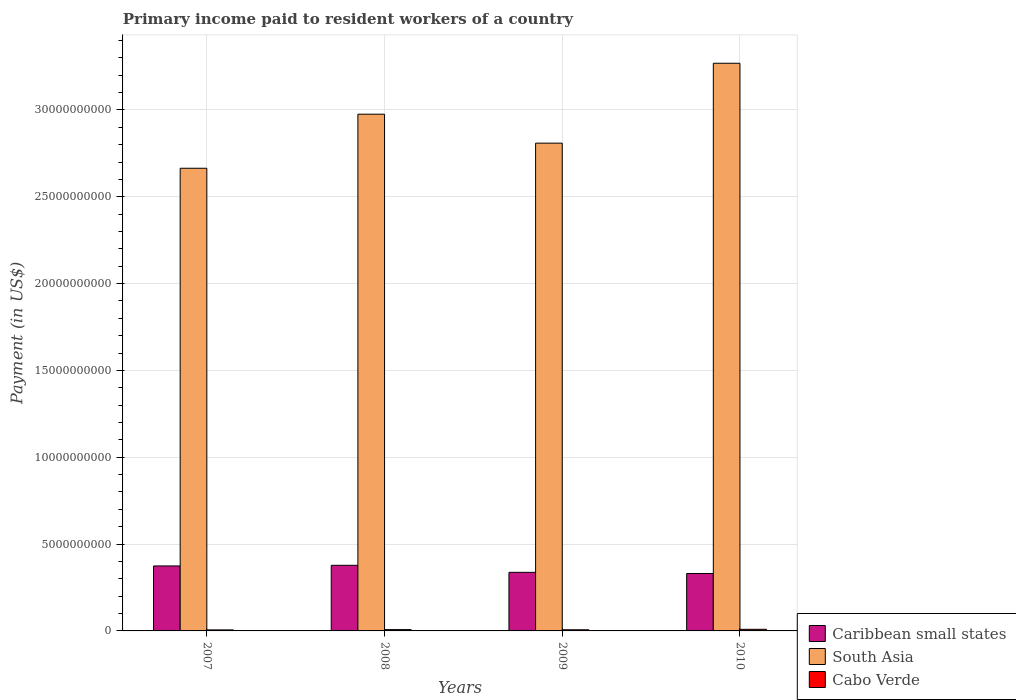How many different coloured bars are there?
Your answer should be compact. 3. How many groups of bars are there?
Keep it short and to the point. 4. Are the number of bars on each tick of the X-axis equal?
Keep it short and to the point. Yes. How many bars are there on the 3rd tick from the right?
Offer a terse response. 3. What is the label of the 1st group of bars from the left?
Your response must be concise. 2007. What is the amount paid to workers in Caribbean small states in 2010?
Your answer should be compact. 3.31e+09. Across all years, what is the maximum amount paid to workers in Cabo Verde?
Offer a very short reply. 9.31e+07. Across all years, what is the minimum amount paid to workers in Caribbean small states?
Provide a succinct answer. 3.31e+09. In which year was the amount paid to workers in South Asia maximum?
Offer a terse response. 2010. In which year was the amount paid to workers in Caribbean small states minimum?
Your response must be concise. 2010. What is the total amount paid to workers in South Asia in the graph?
Offer a very short reply. 1.17e+11. What is the difference between the amount paid to workers in Caribbean small states in 2007 and that in 2010?
Ensure brevity in your answer.  4.35e+08. What is the difference between the amount paid to workers in Cabo Verde in 2007 and the amount paid to workers in South Asia in 2010?
Provide a short and direct response. -3.26e+1. What is the average amount paid to workers in Caribbean small states per year?
Ensure brevity in your answer.  3.55e+09. In the year 2008, what is the difference between the amount paid to workers in Cabo Verde and amount paid to workers in South Asia?
Your answer should be very brief. -2.97e+1. In how many years, is the amount paid to workers in Caribbean small states greater than 26000000000 US$?
Make the answer very short. 0. What is the ratio of the amount paid to workers in Cabo Verde in 2008 to that in 2009?
Provide a succinct answer. 1.14. What is the difference between the highest and the second highest amount paid to workers in South Asia?
Offer a very short reply. 2.93e+09. What is the difference between the highest and the lowest amount paid to workers in Cabo Verde?
Keep it short and to the point. 3.42e+07. Is the sum of the amount paid to workers in Caribbean small states in 2008 and 2009 greater than the maximum amount paid to workers in Cabo Verde across all years?
Offer a terse response. Yes. What does the 3rd bar from the left in 2007 represents?
Keep it short and to the point. Cabo Verde. What does the 2nd bar from the right in 2008 represents?
Offer a terse response. South Asia. Is it the case that in every year, the sum of the amount paid to workers in South Asia and amount paid to workers in Cabo Verde is greater than the amount paid to workers in Caribbean small states?
Provide a short and direct response. Yes. Are all the bars in the graph horizontal?
Provide a short and direct response. No. What is the difference between two consecutive major ticks on the Y-axis?
Your answer should be compact. 5.00e+09. Are the values on the major ticks of Y-axis written in scientific E-notation?
Offer a terse response. No. Does the graph contain any zero values?
Keep it short and to the point. No. Does the graph contain grids?
Make the answer very short. Yes. Where does the legend appear in the graph?
Provide a succinct answer. Bottom right. How many legend labels are there?
Offer a terse response. 3. How are the legend labels stacked?
Your answer should be very brief. Vertical. What is the title of the graph?
Your answer should be very brief. Primary income paid to resident workers of a country. Does "Tuvalu" appear as one of the legend labels in the graph?
Provide a succinct answer. No. What is the label or title of the Y-axis?
Keep it short and to the point. Payment (in US$). What is the Payment (in US$) of Caribbean small states in 2007?
Offer a very short reply. 3.74e+09. What is the Payment (in US$) of South Asia in 2007?
Provide a short and direct response. 2.66e+1. What is the Payment (in US$) in Cabo Verde in 2007?
Ensure brevity in your answer.  5.89e+07. What is the Payment (in US$) in Caribbean small states in 2008?
Your response must be concise. 3.78e+09. What is the Payment (in US$) of South Asia in 2008?
Your response must be concise. 2.98e+1. What is the Payment (in US$) of Cabo Verde in 2008?
Offer a very short reply. 7.57e+07. What is the Payment (in US$) of Caribbean small states in 2009?
Your response must be concise. 3.37e+09. What is the Payment (in US$) of South Asia in 2009?
Offer a very short reply. 2.81e+1. What is the Payment (in US$) in Cabo Verde in 2009?
Provide a succinct answer. 6.63e+07. What is the Payment (in US$) in Caribbean small states in 2010?
Your answer should be compact. 3.31e+09. What is the Payment (in US$) of South Asia in 2010?
Make the answer very short. 3.27e+1. What is the Payment (in US$) in Cabo Verde in 2010?
Your response must be concise. 9.31e+07. Across all years, what is the maximum Payment (in US$) in Caribbean small states?
Offer a very short reply. 3.78e+09. Across all years, what is the maximum Payment (in US$) of South Asia?
Your answer should be compact. 3.27e+1. Across all years, what is the maximum Payment (in US$) in Cabo Verde?
Provide a short and direct response. 9.31e+07. Across all years, what is the minimum Payment (in US$) in Caribbean small states?
Make the answer very short. 3.31e+09. Across all years, what is the minimum Payment (in US$) in South Asia?
Keep it short and to the point. 2.66e+1. Across all years, what is the minimum Payment (in US$) in Cabo Verde?
Make the answer very short. 5.89e+07. What is the total Payment (in US$) in Caribbean small states in the graph?
Your answer should be compact. 1.42e+1. What is the total Payment (in US$) of South Asia in the graph?
Ensure brevity in your answer.  1.17e+11. What is the total Payment (in US$) in Cabo Verde in the graph?
Keep it short and to the point. 2.94e+08. What is the difference between the Payment (in US$) in Caribbean small states in 2007 and that in 2008?
Provide a short and direct response. -3.64e+07. What is the difference between the Payment (in US$) of South Asia in 2007 and that in 2008?
Ensure brevity in your answer.  -3.11e+09. What is the difference between the Payment (in US$) in Cabo Verde in 2007 and that in 2008?
Make the answer very short. -1.68e+07. What is the difference between the Payment (in US$) in Caribbean small states in 2007 and that in 2009?
Your answer should be compact. 3.68e+08. What is the difference between the Payment (in US$) in South Asia in 2007 and that in 2009?
Your answer should be very brief. -1.45e+09. What is the difference between the Payment (in US$) in Cabo Verde in 2007 and that in 2009?
Your answer should be very brief. -7.39e+06. What is the difference between the Payment (in US$) of Caribbean small states in 2007 and that in 2010?
Offer a very short reply. 4.35e+08. What is the difference between the Payment (in US$) of South Asia in 2007 and that in 2010?
Your answer should be very brief. -6.05e+09. What is the difference between the Payment (in US$) in Cabo Verde in 2007 and that in 2010?
Give a very brief answer. -3.42e+07. What is the difference between the Payment (in US$) of Caribbean small states in 2008 and that in 2009?
Make the answer very short. 4.05e+08. What is the difference between the Payment (in US$) in South Asia in 2008 and that in 2009?
Provide a short and direct response. 1.67e+09. What is the difference between the Payment (in US$) in Cabo Verde in 2008 and that in 2009?
Your answer should be compact. 9.44e+06. What is the difference between the Payment (in US$) in Caribbean small states in 2008 and that in 2010?
Provide a succinct answer. 4.71e+08. What is the difference between the Payment (in US$) of South Asia in 2008 and that in 2010?
Your answer should be very brief. -2.93e+09. What is the difference between the Payment (in US$) in Cabo Verde in 2008 and that in 2010?
Your answer should be very brief. -1.73e+07. What is the difference between the Payment (in US$) in Caribbean small states in 2009 and that in 2010?
Provide a succinct answer. 6.67e+07. What is the difference between the Payment (in US$) of South Asia in 2009 and that in 2010?
Your answer should be very brief. -4.60e+09. What is the difference between the Payment (in US$) of Cabo Verde in 2009 and that in 2010?
Offer a terse response. -2.68e+07. What is the difference between the Payment (in US$) in Caribbean small states in 2007 and the Payment (in US$) in South Asia in 2008?
Provide a succinct answer. -2.60e+1. What is the difference between the Payment (in US$) of Caribbean small states in 2007 and the Payment (in US$) of Cabo Verde in 2008?
Your response must be concise. 3.67e+09. What is the difference between the Payment (in US$) in South Asia in 2007 and the Payment (in US$) in Cabo Verde in 2008?
Provide a short and direct response. 2.66e+1. What is the difference between the Payment (in US$) in Caribbean small states in 2007 and the Payment (in US$) in South Asia in 2009?
Offer a terse response. -2.43e+1. What is the difference between the Payment (in US$) of Caribbean small states in 2007 and the Payment (in US$) of Cabo Verde in 2009?
Give a very brief answer. 3.68e+09. What is the difference between the Payment (in US$) in South Asia in 2007 and the Payment (in US$) in Cabo Verde in 2009?
Provide a short and direct response. 2.66e+1. What is the difference between the Payment (in US$) of Caribbean small states in 2007 and the Payment (in US$) of South Asia in 2010?
Your answer should be compact. -2.89e+1. What is the difference between the Payment (in US$) in Caribbean small states in 2007 and the Payment (in US$) in Cabo Verde in 2010?
Your answer should be compact. 3.65e+09. What is the difference between the Payment (in US$) of South Asia in 2007 and the Payment (in US$) of Cabo Verde in 2010?
Your answer should be compact. 2.66e+1. What is the difference between the Payment (in US$) in Caribbean small states in 2008 and the Payment (in US$) in South Asia in 2009?
Your answer should be very brief. -2.43e+1. What is the difference between the Payment (in US$) of Caribbean small states in 2008 and the Payment (in US$) of Cabo Verde in 2009?
Your answer should be compact. 3.71e+09. What is the difference between the Payment (in US$) of South Asia in 2008 and the Payment (in US$) of Cabo Verde in 2009?
Keep it short and to the point. 2.97e+1. What is the difference between the Payment (in US$) of Caribbean small states in 2008 and the Payment (in US$) of South Asia in 2010?
Your answer should be very brief. -2.89e+1. What is the difference between the Payment (in US$) of Caribbean small states in 2008 and the Payment (in US$) of Cabo Verde in 2010?
Make the answer very short. 3.69e+09. What is the difference between the Payment (in US$) of South Asia in 2008 and the Payment (in US$) of Cabo Verde in 2010?
Give a very brief answer. 2.97e+1. What is the difference between the Payment (in US$) of Caribbean small states in 2009 and the Payment (in US$) of South Asia in 2010?
Give a very brief answer. -2.93e+1. What is the difference between the Payment (in US$) in Caribbean small states in 2009 and the Payment (in US$) in Cabo Verde in 2010?
Your answer should be very brief. 3.28e+09. What is the difference between the Payment (in US$) in South Asia in 2009 and the Payment (in US$) in Cabo Verde in 2010?
Ensure brevity in your answer.  2.80e+1. What is the average Payment (in US$) in Caribbean small states per year?
Your response must be concise. 3.55e+09. What is the average Payment (in US$) in South Asia per year?
Ensure brevity in your answer.  2.93e+1. What is the average Payment (in US$) of Cabo Verde per year?
Offer a terse response. 7.35e+07. In the year 2007, what is the difference between the Payment (in US$) in Caribbean small states and Payment (in US$) in South Asia?
Ensure brevity in your answer.  -2.29e+1. In the year 2007, what is the difference between the Payment (in US$) in Caribbean small states and Payment (in US$) in Cabo Verde?
Your answer should be very brief. 3.68e+09. In the year 2007, what is the difference between the Payment (in US$) of South Asia and Payment (in US$) of Cabo Verde?
Provide a short and direct response. 2.66e+1. In the year 2008, what is the difference between the Payment (in US$) in Caribbean small states and Payment (in US$) in South Asia?
Provide a succinct answer. -2.60e+1. In the year 2008, what is the difference between the Payment (in US$) of Caribbean small states and Payment (in US$) of Cabo Verde?
Provide a short and direct response. 3.70e+09. In the year 2008, what is the difference between the Payment (in US$) in South Asia and Payment (in US$) in Cabo Verde?
Provide a succinct answer. 2.97e+1. In the year 2009, what is the difference between the Payment (in US$) of Caribbean small states and Payment (in US$) of South Asia?
Make the answer very short. -2.47e+1. In the year 2009, what is the difference between the Payment (in US$) of Caribbean small states and Payment (in US$) of Cabo Verde?
Give a very brief answer. 3.31e+09. In the year 2009, what is the difference between the Payment (in US$) in South Asia and Payment (in US$) in Cabo Verde?
Offer a very short reply. 2.80e+1. In the year 2010, what is the difference between the Payment (in US$) of Caribbean small states and Payment (in US$) of South Asia?
Your answer should be compact. -2.94e+1. In the year 2010, what is the difference between the Payment (in US$) of Caribbean small states and Payment (in US$) of Cabo Verde?
Give a very brief answer. 3.21e+09. In the year 2010, what is the difference between the Payment (in US$) of South Asia and Payment (in US$) of Cabo Verde?
Make the answer very short. 3.26e+1. What is the ratio of the Payment (in US$) in South Asia in 2007 to that in 2008?
Keep it short and to the point. 0.9. What is the ratio of the Payment (in US$) of Cabo Verde in 2007 to that in 2008?
Offer a terse response. 0.78. What is the ratio of the Payment (in US$) in Caribbean small states in 2007 to that in 2009?
Keep it short and to the point. 1.11. What is the ratio of the Payment (in US$) in South Asia in 2007 to that in 2009?
Give a very brief answer. 0.95. What is the ratio of the Payment (in US$) of Cabo Verde in 2007 to that in 2009?
Give a very brief answer. 0.89. What is the ratio of the Payment (in US$) in Caribbean small states in 2007 to that in 2010?
Provide a short and direct response. 1.13. What is the ratio of the Payment (in US$) in South Asia in 2007 to that in 2010?
Ensure brevity in your answer.  0.81. What is the ratio of the Payment (in US$) of Cabo Verde in 2007 to that in 2010?
Your response must be concise. 0.63. What is the ratio of the Payment (in US$) in Caribbean small states in 2008 to that in 2009?
Make the answer very short. 1.12. What is the ratio of the Payment (in US$) of South Asia in 2008 to that in 2009?
Provide a short and direct response. 1.06. What is the ratio of the Payment (in US$) in Cabo Verde in 2008 to that in 2009?
Offer a terse response. 1.14. What is the ratio of the Payment (in US$) in Caribbean small states in 2008 to that in 2010?
Your answer should be compact. 1.14. What is the ratio of the Payment (in US$) of South Asia in 2008 to that in 2010?
Offer a terse response. 0.91. What is the ratio of the Payment (in US$) of Cabo Verde in 2008 to that in 2010?
Offer a very short reply. 0.81. What is the ratio of the Payment (in US$) of Caribbean small states in 2009 to that in 2010?
Make the answer very short. 1.02. What is the ratio of the Payment (in US$) of South Asia in 2009 to that in 2010?
Provide a short and direct response. 0.86. What is the ratio of the Payment (in US$) in Cabo Verde in 2009 to that in 2010?
Provide a short and direct response. 0.71. What is the difference between the highest and the second highest Payment (in US$) in Caribbean small states?
Ensure brevity in your answer.  3.64e+07. What is the difference between the highest and the second highest Payment (in US$) of South Asia?
Ensure brevity in your answer.  2.93e+09. What is the difference between the highest and the second highest Payment (in US$) of Cabo Verde?
Your answer should be compact. 1.73e+07. What is the difference between the highest and the lowest Payment (in US$) in Caribbean small states?
Keep it short and to the point. 4.71e+08. What is the difference between the highest and the lowest Payment (in US$) in South Asia?
Your response must be concise. 6.05e+09. What is the difference between the highest and the lowest Payment (in US$) of Cabo Verde?
Offer a terse response. 3.42e+07. 